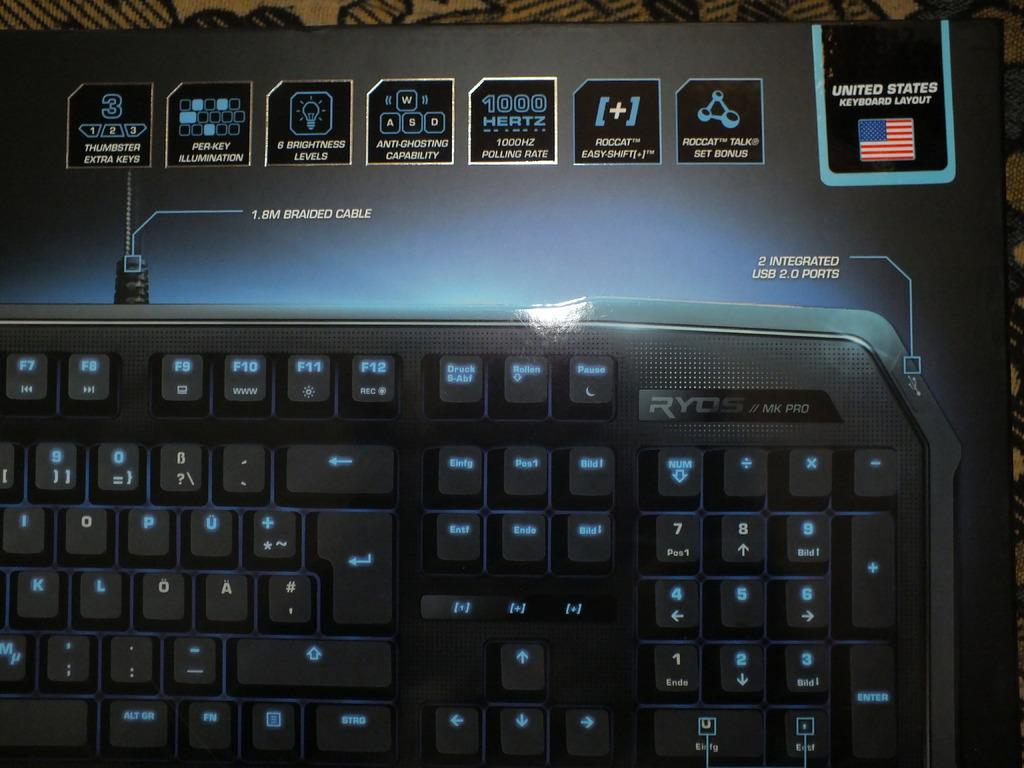<image>
Give a short and clear explanation of the subsequent image. A black keyboard with the USA on it 